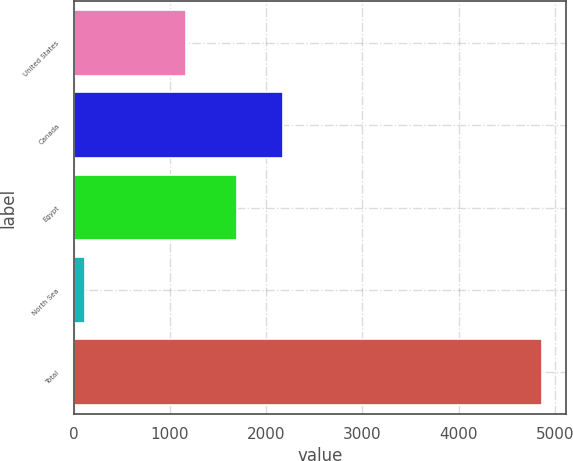<chart> <loc_0><loc_0><loc_500><loc_500><bar_chart><fcel>United States<fcel>Canada<fcel>Egypt<fcel>North Sea<fcel>Total<nl><fcel>1166<fcel>2173.3<fcel>1698<fcel>116<fcel>4869<nl></chart> 